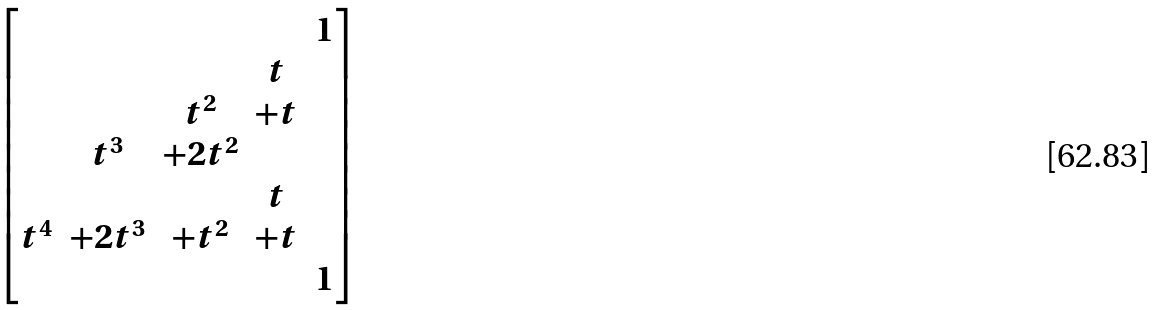Convert formula to latex. <formula><loc_0><loc_0><loc_500><loc_500>\begin{bmatrix} & & & & 1 \\ & & & t & \\ & & t ^ { 2 } & + t & \\ & t ^ { 3 } & + 2 t ^ { 2 } & & \\ & & & t & \\ t ^ { 4 } & + 2 t ^ { 3 } & + t ^ { 2 } & + t & \\ & & & & 1 \end{bmatrix}</formula> 